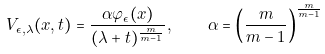Convert formula to latex. <formula><loc_0><loc_0><loc_500><loc_500>V _ { \epsilon , \lambda } ( x , t ) = \frac { \alpha \varphi _ { \epsilon } ( x ) } { ( \lambda + t ) ^ { \frac { m } { m - 1 } } } , \quad \alpha = \left ( \frac { m } { m - 1 } \right ) ^ { \frac { m } { m - 1 } }</formula> 